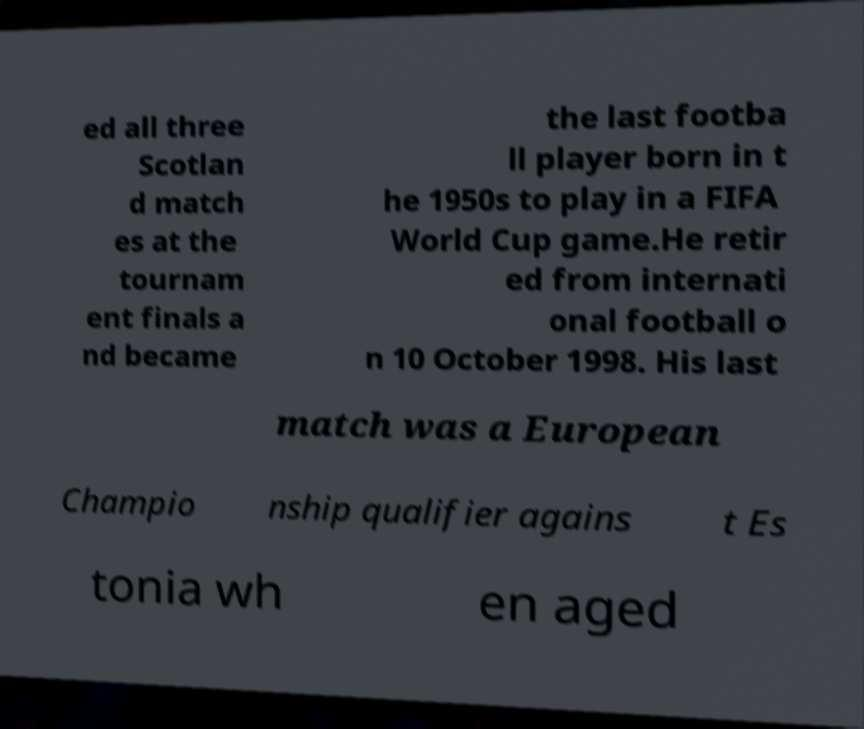Can you accurately transcribe the text from the provided image for me? ed all three Scotlan d match es at the tournam ent finals a nd became the last footba ll player born in t he 1950s to play in a FIFA World Cup game.He retir ed from internati onal football o n 10 October 1998. His last match was a European Champio nship qualifier agains t Es tonia wh en aged 